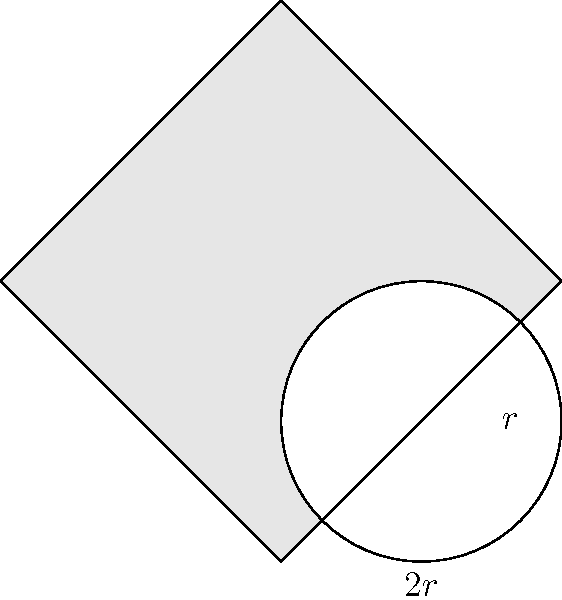In the figure above, a circle with radius $r$ is inscribed in a square with side length $2r$. Calculate the area of the shaded region between the square and the circle in terms of $r$. To find the area of the shaded region, we need to subtract the area of the circle from the area of the square. Let's approach this step-by-step:

1. Calculate the area of the square:
   $$A_{square} = (2r)^2 = 4r^2$$

2. Calculate the area of the circle:
   $$A_{circle} = \pi r^2$$

3. The shaded area is the difference between these two areas:
   $$A_{shaded} = A_{square} - A_{circle}$$
   $$A_{shaded} = 4r^2 - \pi r^2$$
   $$A_{shaded} = r^2(4 - \pi)$$

4. Simplify the expression:
   $$A_{shaded} = (4 - \pi)r^2$$

This final expression represents the area of the shaded region in terms of $r$.
Answer: $(4 - \pi)r^2$ 